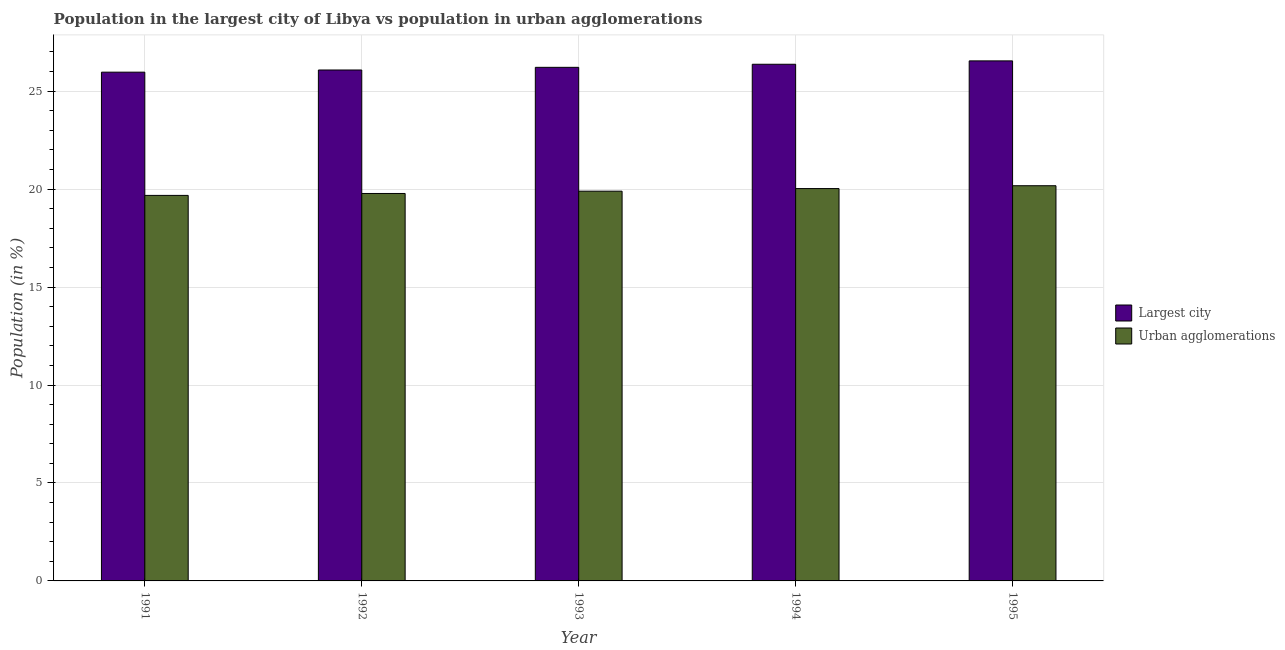How many different coloured bars are there?
Your answer should be compact. 2. In how many cases, is the number of bars for a given year not equal to the number of legend labels?
Give a very brief answer. 0. What is the population in the largest city in 1992?
Provide a succinct answer. 26.08. Across all years, what is the maximum population in the largest city?
Provide a succinct answer. 26.55. Across all years, what is the minimum population in the largest city?
Offer a terse response. 25.97. In which year was the population in urban agglomerations maximum?
Your response must be concise. 1995. What is the total population in the largest city in the graph?
Make the answer very short. 131.18. What is the difference between the population in the largest city in 1992 and that in 1995?
Offer a very short reply. -0.47. What is the difference between the population in urban agglomerations in 1993 and the population in the largest city in 1995?
Ensure brevity in your answer.  -0.28. What is the average population in urban agglomerations per year?
Your response must be concise. 19.91. What is the ratio of the population in urban agglomerations in 1992 to that in 1994?
Make the answer very short. 0.99. Is the population in urban agglomerations in 1993 less than that in 1994?
Offer a terse response. Yes. Is the difference between the population in urban agglomerations in 1993 and 1994 greater than the difference between the population in the largest city in 1993 and 1994?
Give a very brief answer. No. What is the difference between the highest and the second highest population in the largest city?
Provide a succinct answer. 0.17. What is the difference between the highest and the lowest population in urban agglomerations?
Give a very brief answer. 0.49. In how many years, is the population in urban agglomerations greater than the average population in urban agglomerations taken over all years?
Provide a succinct answer. 2. Is the sum of the population in urban agglomerations in 1993 and 1994 greater than the maximum population in the largest city across all years?
Ensure brevity in your answer.  Yes. What does the 2nd bar from the left in 1992 represents?
Provide a succinct answer. Urban agglomerations. What does the 2nd bar from the right in 1991 represents?
Provide a succinct answer. Largest city. How many bars are there?
Offer a terse response. 10. What is the difference between two consecutive major ticks on the Y-axis?
Give a very brief answer. 5. Are the values on the major ticks of Y-axis written in scientific E-notation?
Your answer should be compact. No. Does the graph contain any zero values?
Your answer should be compact. No. Does the graph contain grids?
Ensure brevity in your answer.  Yes. How many legend labels are there?
Make the answer very short. 2. How are the legend labels stacked?
Keep it short and to the point. Vertical. What is the title of the graph?
Your answer should be compact. Population in the largest city of Libya vs population in urban agglomerations. What is the label or title of the Y-axis?
Make the answer very short. Population (in %). What is the Population (in %) of Largest city in 1991?
Ensure brevity in your answer.  25.97. What is the Population (in %) of Urban agglomerations in 1991?
Offer a terse response. 19.68. What is the Population (in %) of Largest city in 1992?
Your response must be concise. 26.08. What is the Population (in %) of Urban agglomerations in 1992?
Provide a short and direct response. 19.78. What is the Population (in %) in Largest city in 1993?
Provide a short and direct response. 26.22. What is the Population (in %) in Urban agglomerations in 1993?
Provide a succinct answer. 19.89. What is the Population (in %) in Largest city in 1994?
Your answer should be compact. 26.37. What is the Population (in %) in Urban agglomerations in 1994?
Make the answer very short. 20.03. What is the Population (in %) of Largest city in 1995?
Provide a short and direct response. 26.55. What is the Population (in %) of Urban agglomerations in 1995?
Provide a short and direct response. 20.17. Across all years, what is the maximum Population (in %) in Largest city?
Offer a very short reply. 26.55. Across all years, what is the maximum Population (in %) in Urban agglomerations?
Provide a succinct answer. 20.17. Across all years, what is the minimum Population (in %) of Largest city?
Your response must be concise. 25.97. Across all years, what is the minimum Population (in %) in Urban agglomerations?
Offer a terse response. 19.68. What is the total Population (in %) in Largest city in the graph?
Your response must be concise. 131.18. What is the total Population (in %) of Urban agglomerations in the graph?
Your answer should be very brief. 99.55. What is the difference between the Population (in %) of Largest city in 1991 and that in 1992?
Your response must be concise. -0.11. What is the difference between the Population (in %) in Urban agglomerations in 1991 and that in 1992?
Make the answer very short. -0.1. What is the difference between the Population (in %) of Largest city in 1991 and that in 1993?
Provide a succinct answer. -0.25. What is the difference between the Population (in %) in Urban agglomerations in 1991 and that in 1993?
Provide a succinct answer. -0.22. What is the difference between the Population (in %) in Largest city in 1991 and that in 1994?
Your answer should be compact. -0.4. What is the difference between the Population (in %) in Urban agglomerations in 1991 and that in 1994?
Give a very brief answer. -0.35. What is the difference between the Population (in %) of Largest city in 1991 and that in 1995?
Make the answer very short. -0.58. What is the difference between the Population (in %) in Urban agglomerations in 1991 and that in 1995?
Keep it short and to the point. -0.49. What is the difference between the Population (in %) of Largest city in 1992 and that in 1993?
Provide a short and direct response. -0.14. What is the difference between the Population (in %) in Urban agglomerations in 1992 and that in 1993?
Provide a succinct answer. -0.12. What is the difference between the Population (in %) in Largest city in 1992 and that in 1994?
Provide a succinct answer. -0.29. What is the difference between the Population (in %) of Urban agglomerations in 1992 and that in 1994?
Ensure brevity in your answer.  -0.25. What is the difference between the Population (in %) in Largest city in 1992 and that in 1995?
Keep it short and to the point. -0.47. What is the difference between the Population (in %) of Urban agglomerations in 1992 and that in 1995?
Offer a very short reply. -0.4. What is the difference between the Population (in %) in Largest city in 1993 and that in 1994?
Your answer should be compact. -0.16. What is the difference between the Population (in %) of Urban agglomerations in 1993 and that in 1994?
Provide a succinct answer. -0.13. What is the difference between the Population (in %) of Largest city in 1993 and that in 1995?
Keep it short and to the point. -0.33. What is the difference between the Population (in %) of Urban agglomerations in 1993 and that in 1995?
Give a very brief answer. -0.28. What is the difference between the Population (in %) of Largest city in 1994 and that in 1995?
Keep it short and to the point. -0.17. What is the difference between the Population (in %) of Urban agglomerations in 1994 and that in 1995?
Your answer should be compact. -0.15. What is the difference between the Population (in %) of Largest city in 1991 and the Population (in %) of Urban agglomerations in 1992?
Make the answer very short. 6.19. What is the difference between the Population (in %) of Largest city in 1991 and the Population (in %) of Urban agglomerations in 1993?
Offer a terse response. 6.07. What is the difference between the Population (in %) in Largest city in 1991 and the Population (in %) in Urban agglomerations in 1994?
Give a very brief answer. 5.94. What is the difference between the Population (in %) of Largest city in 1991 and the Population (in %) of Urban agglomerations in 1995?
Give a very brief answer. 5.8. What is the difference between the Population (in %) of Largest city in 1992 and the Population (in %) of Urban agglomerations in 1993?
Provide a short and direct response. 6.19. What is the difference between the Population (in %) of Largest city in 1992 and the Population (in %) of Urban agglomerations in 1994?
Keep it short and to the point. 6.05. What is the difference between the Population (in %) in Largest city in 1992 and the Population (in %) in Urban agglomerations in 1995?
Your answer should be very brief. 5.91. What is the difference between the Population (in %) of Largest city in 1993 and the Population (in %) of Urban agglomerations in 1994?
Make the answer very short. 6.19. What is the difference between the Population (in %) in Largest city in 1993 and the Population (in %) in Urban agglomerations in 1995?
Ensure brevity in your answer.  6.04. What is the difference between the Population (in %) of Largest city in 1994 and the Population (in %) of Urban agglomerations in 1995?
Your answer should be compact. 6.2. What is the average Population (in %) in Largest city per year?
Provide a short and direct response. 26.24. What is the average Population (in %) of Urban agglomerations per year?
Ensure brevity in your answer.  19.91. In the year 1991, what is the difference between the Population (in %) in Largest city and Population (in %) in Urban agglomerations?
Provide a succinct answer. 6.29. In the year 1992, what is the difference between the Population (in %) in Largest city and Population (in %) in Urban agglomerations?
Provide a short and direct response. 6.3. In the year 1993, what is the difference between the Population (in %) in Largest city and Population (in %) in Urban agglomerations?
Offer a very short reply. 6.32. In the year 1994, what is the difference between the Population (in %) of Largest city and Population (in %) of Urban agglomerations?
Provide a succinct answer. 6.35. In the year 1995, what is the difference between the Population (in %) in Largest city and Population (in %) in Urban agglomerations?
Your response must be concise. 6.37. What is the ratio of the Population (in %) in Urban agglomerations in 1991 to that in 1992?
Provide a succinct answer. 0.99. What is the ratio of the Population (in %) of Largest city in 1991 to that in 1993?
Provide a succinct answer. 0.99. What is the ratio of the Population (in %) in Largest city in 1991 to that in 1994?
Ensure brevity in your answer.  0.98. What is the ratio of the Population (in %) in Urban agglomerations in 1991 to that in 1994?
Your answer should be compact. 0.98. What is the ratio of the Population (in %) in Largest city in 1991 to that in 1995?
Give a very brief answer. 0.98. What is the ratio of the Population (in %) of Urban agglomerations in 1991 to that in 1995?
Give a very brief answer. 0.98. What is the ratio of the Population (in %) in Largest city in 1992 to that in 1993?
Your answer should be compact. 0.99. What is the ratio of the Population (in %) of Urban agglomerations in 1992 to that in 1993?
Provide a succinct answer. 0.99. What is the ratio of the Population (in %) of Largest city in 1992 to that in 1994?
Your answer should be very brief. 0.99. What is the ratio of the Population (in %) in Urban agglomerations in 1992 to that in 1994?
Provide a succinct answer. 0.99. What is the ratio of the Population (in %) of Largest city in 1992 to that in 1995?
Provide a succinct answer. 0.98. What is the ratio of the Population (in %) in Urban agglomerations in 1992 to that in 1995?
Offer a terse response. 0.98. What is the ratio of the Population (in %) of Largest city in 1993 to that in 1994?
Your answer should be compact. 0.99. What is the ratio of the Population (in %) of Urban agglomerations in 1993 to that in 1994?
Ensure brevity in your answer.  0.99. What is the ratio of the Population (in %) of Largest city in 1993 to that in 1995?
Keep it short and to the point. 0.99. What is the ratio of the Population (in %) in Urban agglomerations in 1993 to that in 1995?
Provide a succinct answer. 0.99. What is the ratio of the Population (in %) in Largest city in 1994 to that in 1995?
Keep it short and to the point. 0.99. What is the difference between the highest and the second highest Population (in %) of Largest city?
Your answer should be compact. 0.17. What is the difference between the highest and the second highest Population (in %) of Urban agglomerations?
Your response must be concise. 0.15. What is the difference between the highest and the lowest Population (in %) in Largest city?
Ensure brevity in your answer.  0.58. What is the difference between the highest and the lowest Population (in %) in Urban agglomerations?
Make the answer very short. 0.49. 